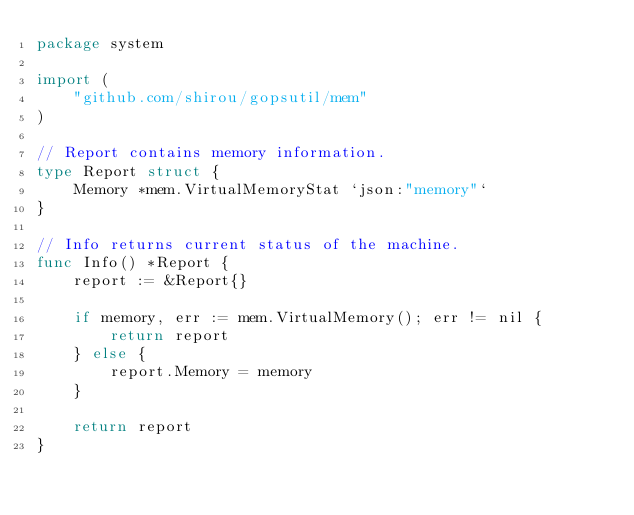<code> <loc_0><loc_0><loc_500><loc_500><_Go_>package system

import (
	"github.com/shirou/gopsutil/mem"
)

// Report contains memory information.
type Report struct {
	Memory *mem.VirtualMemoryStat `json:"memory"`
}

// Info returns current status of the machine.
func Info() *Report {
	report := &Report{}

	if memory, err := mem.VirtualMemory(); err != nil {
		return report
	} else {
		report.Memory = memory
	}

	return report
}
</code> 